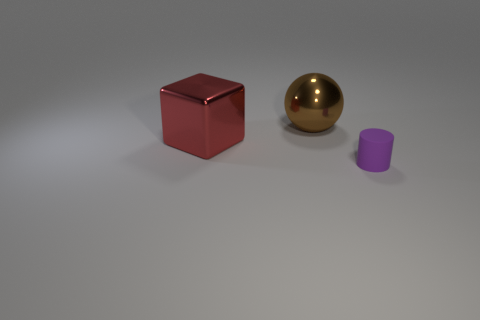Add 2 red metal things. How many objects exist? 5 Subtract all cylinders. How many objects are left? 2 Subtract 1 brown balls. How many objects are left? 2 Subtract all large blue things. Subtract all tiny purple things. How many objects are left? 2 Add 1 big shiny spheres. How many big shiny spheres are left? 2 Add 2 cylinders. How many cylinders exist? 3 